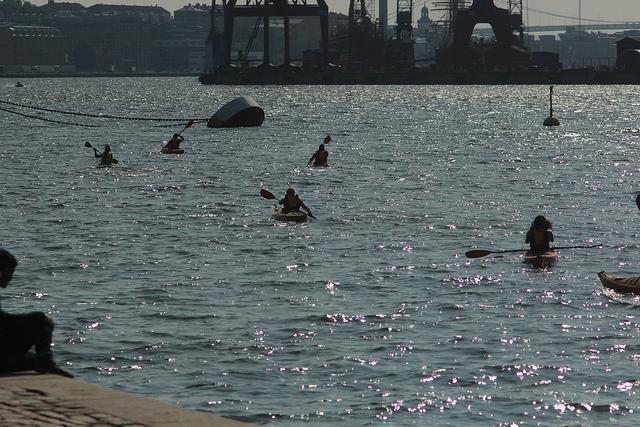How many people are kayaking?
Give a very brief answer. 5. How many birds are in the picture?
Give a very brief answer. 0. 